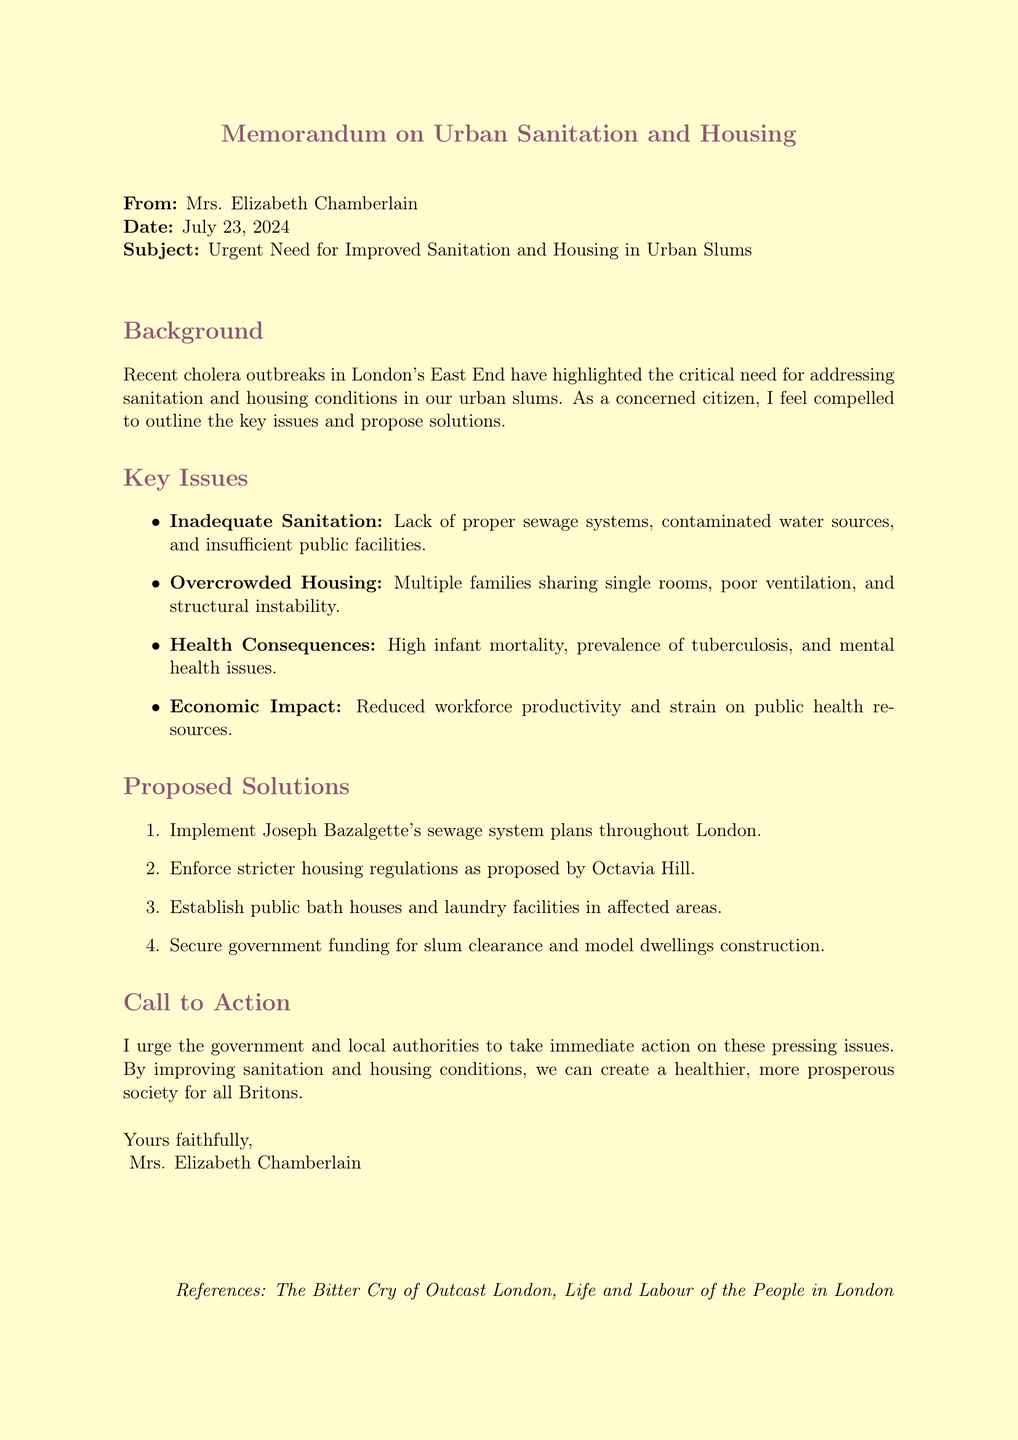What is the name of the author? The document states that the memo is from Mrs. Elizabeth Chamberlain.
Answer: Mrs. Elizabeth Chamberlain What major event prompted this memo? The context of the memo mentions a cholera outbreak that drove attention to sanitation and housing conditions.
Answer: Cholera outbreak What are two key issues highlighted in the main points? The document outlines inadequate sanitation and overcrowded housing as critical issues.
Answer: Inadequate sanitation, Overcrowded housing Name one proposed solution for improving sanitation. The memo lists implementing Joseph Bazalgette's sewage system plans as a solution.
Answer: Joseph Bazalgette's sewage system plans Which social reformer is mentioned regarding housing regulations? Octavia Hill is referenced in the document as an advocate for stricter housing regulations.
Answer: Octavia Hill What is the conclusion's call to action? The memo implores immediate action from the government and local authorities on pressing sanitation and housing issues.
Answer: Immediate action What is the economic impact mentioned in the main points? The memo discusses reduced productivity due to the ill health of the workforce as an economic consequence.
Answer: Reduced productivity How many main points are discussed regarding sanitation and housing? The document outlines four specific main points on the issues of sanitation and housing.
Answer: Four Which area in London is specifically mentioned for high infant mortality rates? The memo states that Bethnal Green is an area noted for high infant mortality rates.
Answer: Bethnal Green 